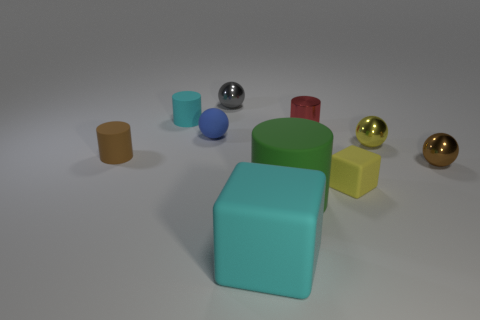What size is the thing that is the same color as the big matte cube?
Offer a terse response. Small. There is a small shiny thing that is right of the yellow thing that is behind the small brown metal object; what is its shape?
Ensure brevity in your answer.  Sphere. Are there any red cylinders made of the same material as the tiny block?
Make the answer very short. No. What is the color of the other small matte object that is the same shape as the tiny gray thing?
Provide a succinct answer. Blue. Is the number of tiny cyan objects on the right side of the brown shiny ball less than the number of tiny balls left of the tiny cyan thing?
Your response must be concise. No. What number of other objects are there of the same shape as the tiny gray object?
Provide a succinct answer. 3. Are there fewer red metallic cylinders that are in front of the yellow sphere than large cyan matte cubes?
Offer a terse response. Yes. What material is the block that is left of the tiny metal cylinder?
Make the answer very short. Rubber. What number of other things are there of the same size as the brown rubber cylinder?
Ensure brevity in your answer.  7. Is the number of blue blocks less than the number of tiny yellow matte objects?
Provide a succinct answer. Yes. 